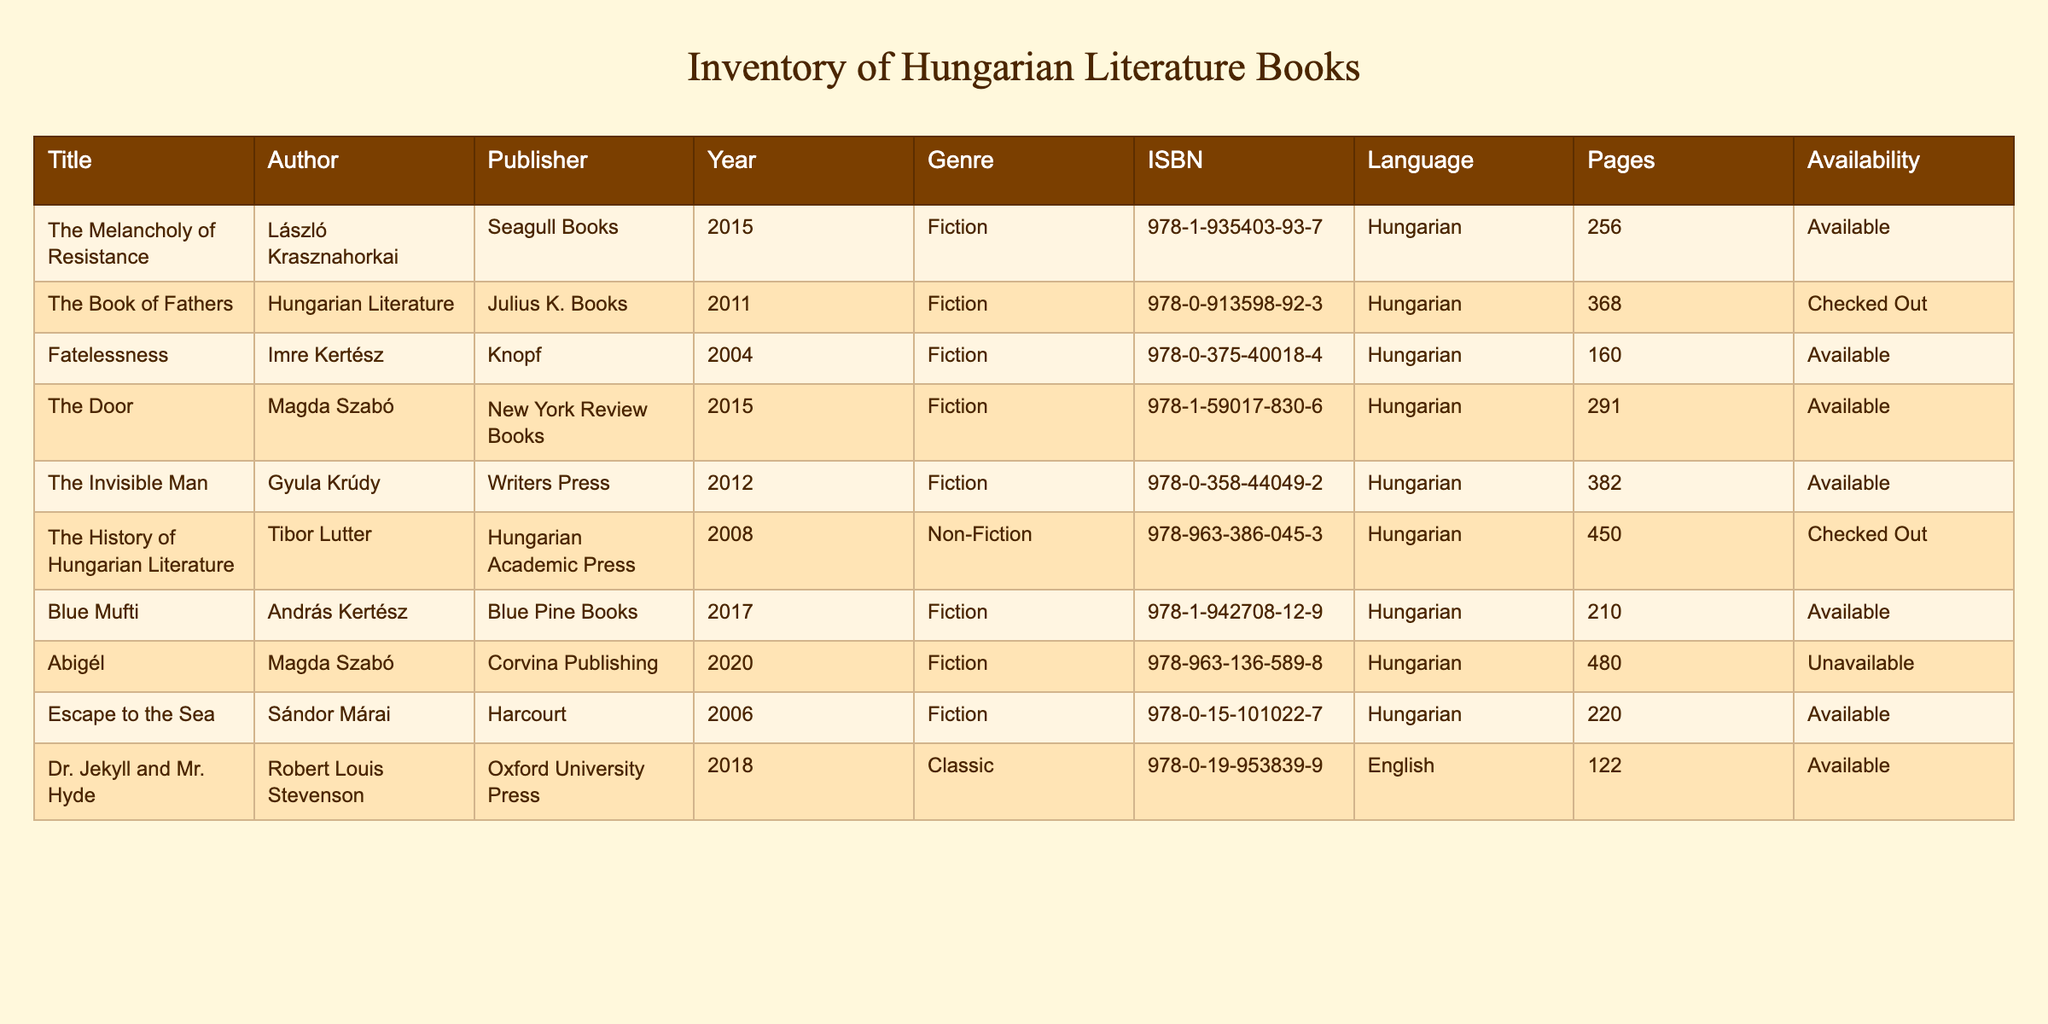What is the title of the book authored by Tibor Lutter? The table lists all books along with their authors. By scanning through the ‘Author’ column, the book associated with Tibor Lutter is identified under the title: "The History of Hungarian Literature."
Answer: "The History of Hungarian Literature" How many pages does "Abigél" have? From the table, I can look for the entry under the title "Abigél" and find the corresponding number of pages listed, which is 480.
Answer: 480 Which books are currently checked out? The availability column indicates whether the books are available or checked out. Scanning through the column, I find "The Book of Fathers" and "The History of Hungarian Literature" are both checked out.
Answer: "The Book of Fathers", "The History of Hungarian Literature" Is "Fatelessness" available in the library? By checking the availability column for the book titled "Fatelessness," I see that it is noted as "Available."
Answer: Yes What is the average number of pages for the available books? First, I identify the titles that are listed as available: "The Melancholy of Resistance" (256), "Fatelessness" (160), "The Door" (291), "The Invisible Man" (382), "Blue Mufti" (210), and "Escape to the Sea" (220). Then I add: 256 + 160 + 291 + 382 + 210 + 220 = 1519. There are 6 available books. To find the average, I divide the total pages by 6: 1519 / 6 ≈ 253.17.
Answer: Approximately 253 How many authors have works included in the inventory? I list the unique authors from the data, which are: László Krasznahorkai, Imre Kertész, Magda Szabó, Gyula Krúdy, András Kertész, Sándor Márai, Robert Louis Stevenson, and Tibor Lutter. Counting these distinct authors gives us a total of 8.
Answer: 8 